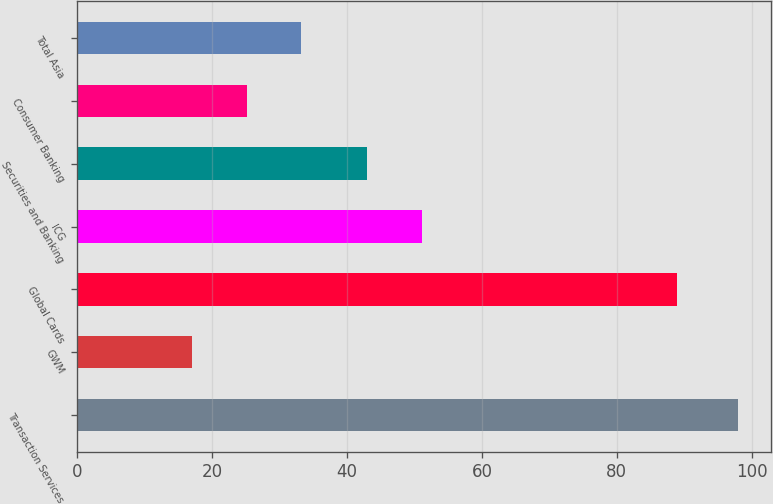Convert chart. <chart><loc_0><loc_0><loc_500><loc_500><bar_chart><fcel>Transaction Services<fcel>GWM<fcel>Global Cards<fcel>ICG<fcel>Securities and Banking<fcel>Consumer Banking<fcel>Total Asia<nl><fcel>98<fcel>17<fcel>89<fcel>51.1<fcel>43<fcel>25.1<fcel>33.2<nl></chart> 